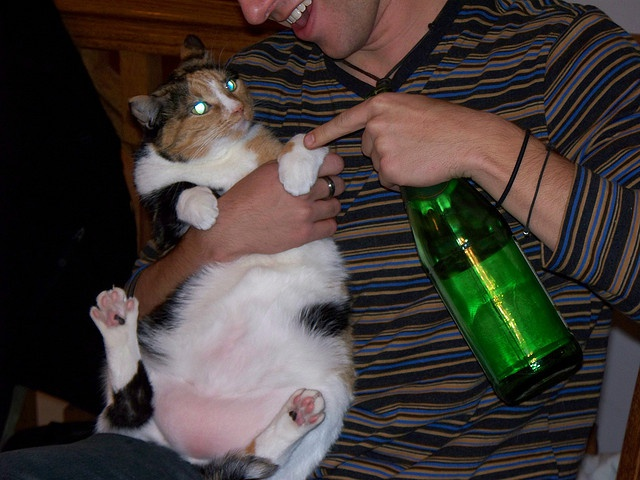Describe the objects in this image and their specific colors. I can see people in black, brown, and maroon tones, cat in black, darkgray, and gray tones, people in black and gray tones, and bottle in black, darkgreen, and green tones in this image. 